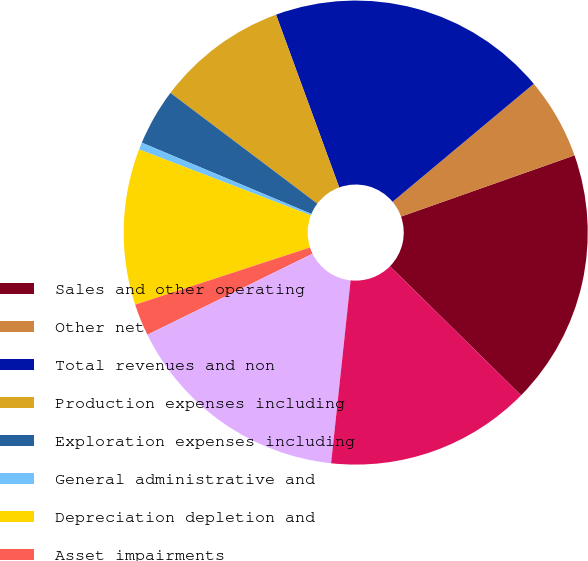<chart> <loc_0><loc_0><loc_500><loc_500><pie_chart><fcel>Sales and other operating<fcel>Other net<fcel>Total revenues and non<fcel>Production expenses including<fcel>Exploration expenses including<fcel>General administrative and<fcel>Depreciation depletion and<fcel>Asset impairments<fcel>Total costs and expenses<fcel>Results of operations before<nl><fcel>17.77%<fcel>5.68%<fcel>19.5%<fcel>9.14%<fcel>3.95%<fcel>0.5%<fcel>10.86%<fcel>2.23%<fcel>16.05%<fcel>14.32%<nl></chart> 